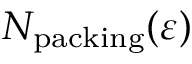Convert formula to latex. <formula><loc_0><loc_0><loc_500><loc_500>N _ { p a c k i n g } ( \varepsilon )</formula> 